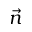Convert formula to latex. <formula><loc_0><loc_0><loc_500><loc_500>\vec { n }</formula> 